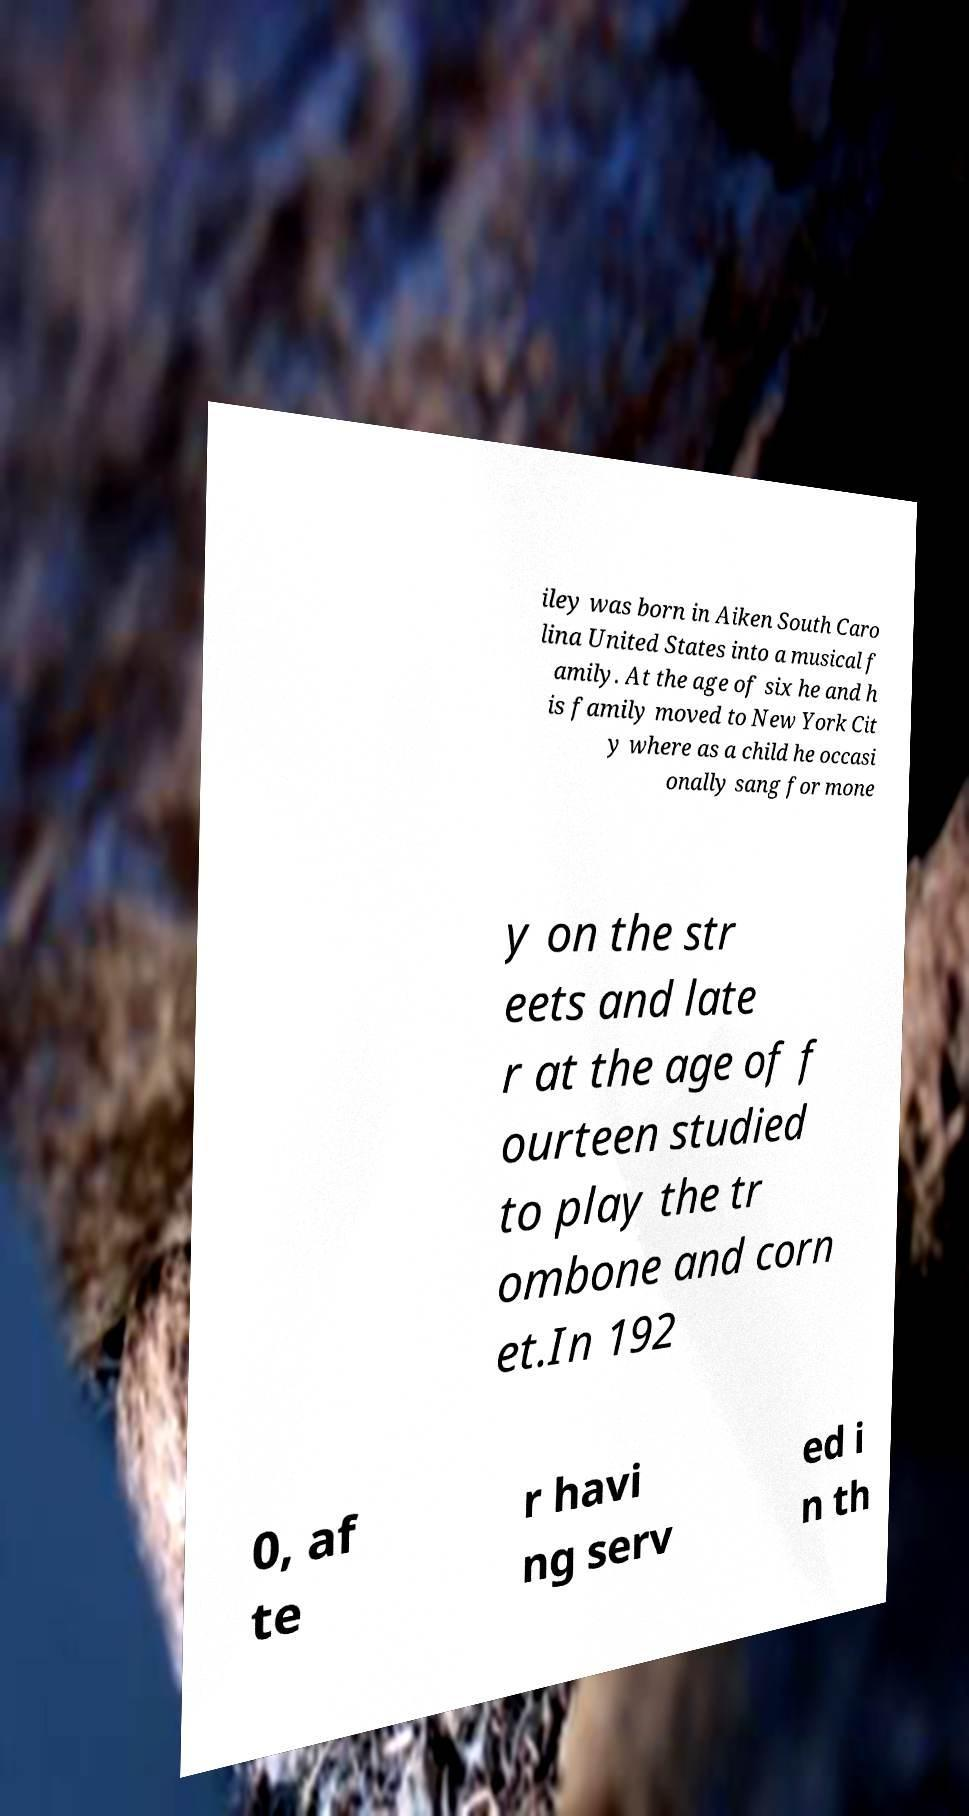For documentation purposes, I need the text within this image transcribed. Could you provide that? iley was born in Aiken South Caro lina United States into a musical f amily. At the age of six he and h is family moved to New York Cit y where as a child he occasi onally sang for mone y on the str eets and late r at the age of f ourteen studied to play the tr ombone and corn et.In 192 0, af te r havi ng serv ed i n th 